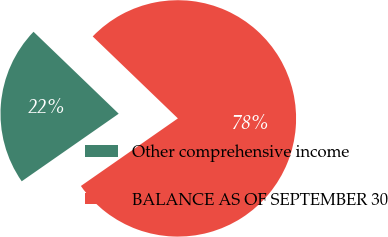Convert chart. <chart><loc_0><loc_0><loc_500><loc_500><pie_chart><fcel>Other comprehensive income<fcel>BALANCE AS OF SEPTEMBER 30<nl><fcel>21.88%<fcel>78.12%<nl></chart> 